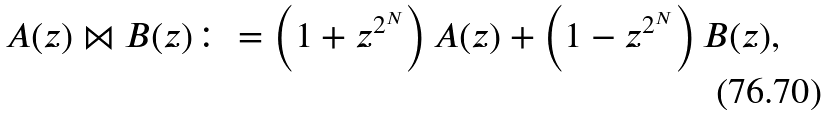<formula> <loc_0><loc_0><loc_500><loc_500>A ( z ) \bowtie B ( z ) \colon = \left ( 1 + z ^ { 2 ^ { N } } \right ) A ( z ) + \left ( 1 - z ^ { 2 ^ { N } } \right ) B ( z ) ,</formula> 